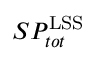Convert formula to latex. <formula><loc_0><loc_0><loc_500><loc_500>S P _ { t o t } ^ { L S S }</formula> 